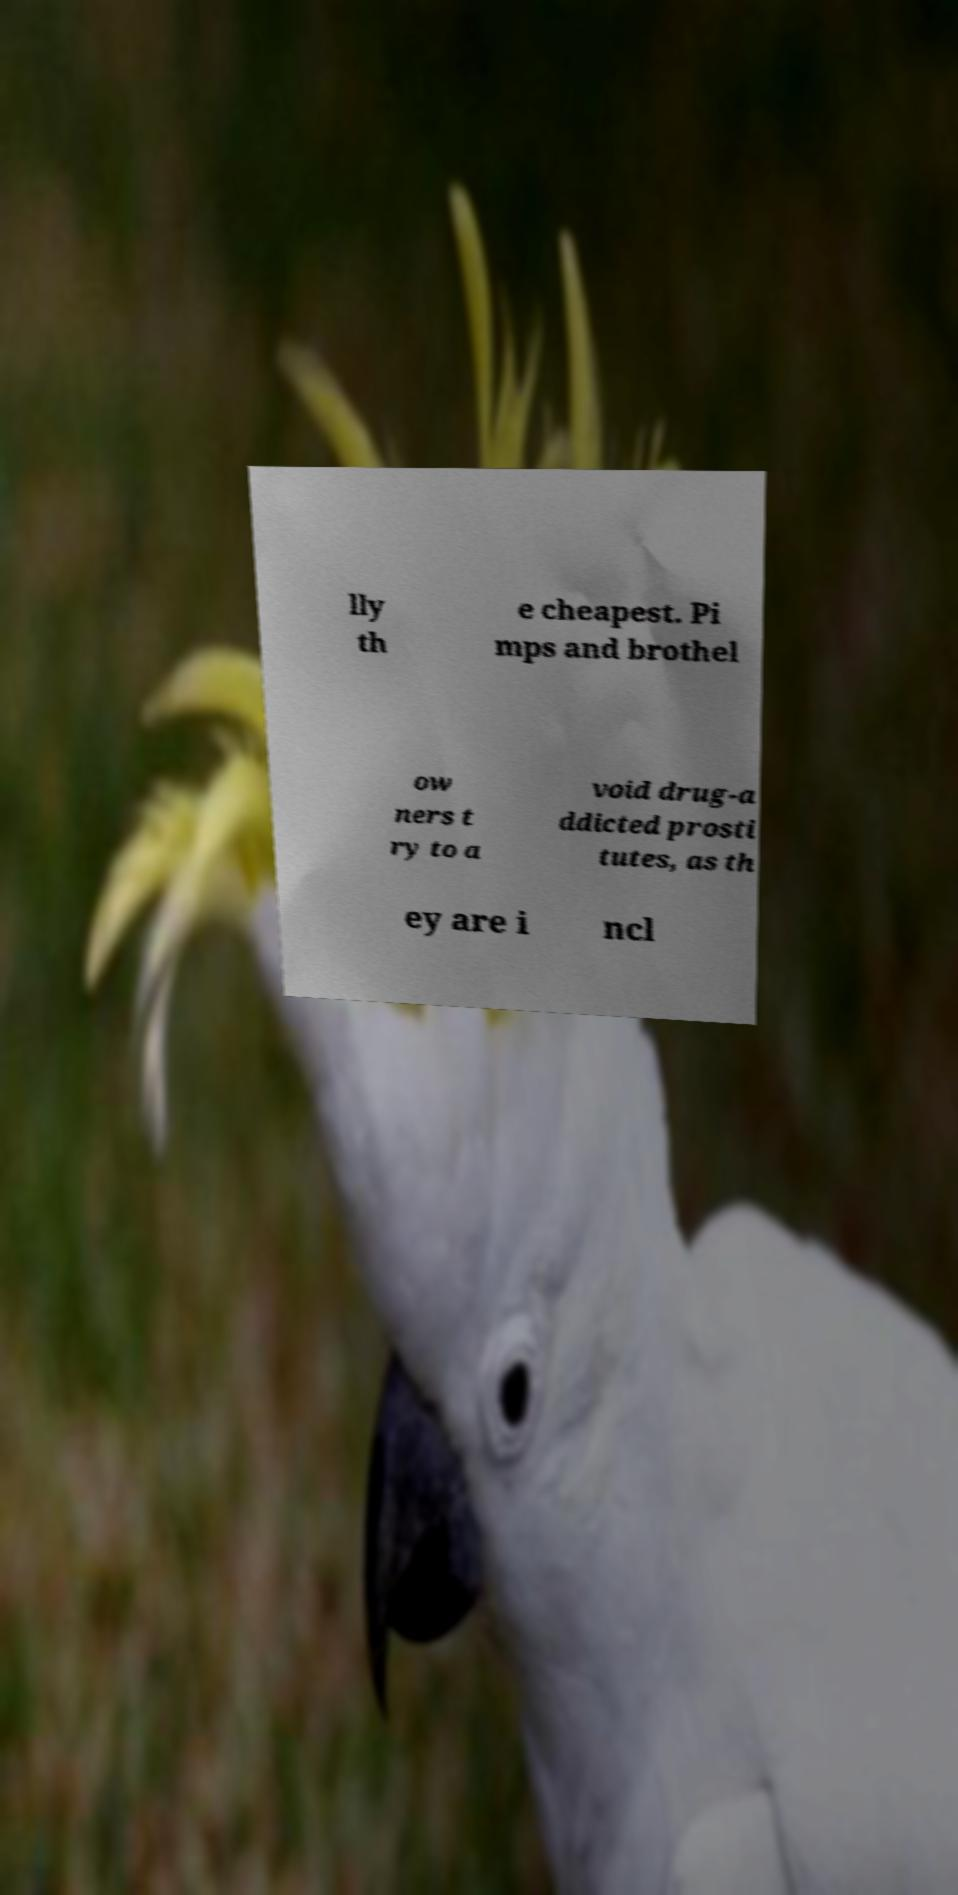Can you read and provide the text displayed in the image?This photo seems to have some interesting text. Can you extract and type it out for me? lly th e cheapest. Pi mps and brothel ow ners t ry to a void drug-a ddicted prosti tutes, as th ey are i ncl 